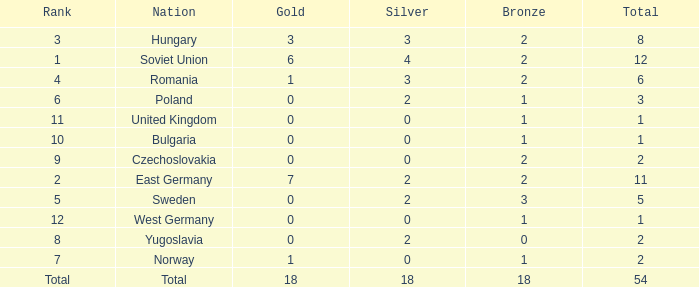What's the highest total of Romania when the bronze was less than 2? None. 